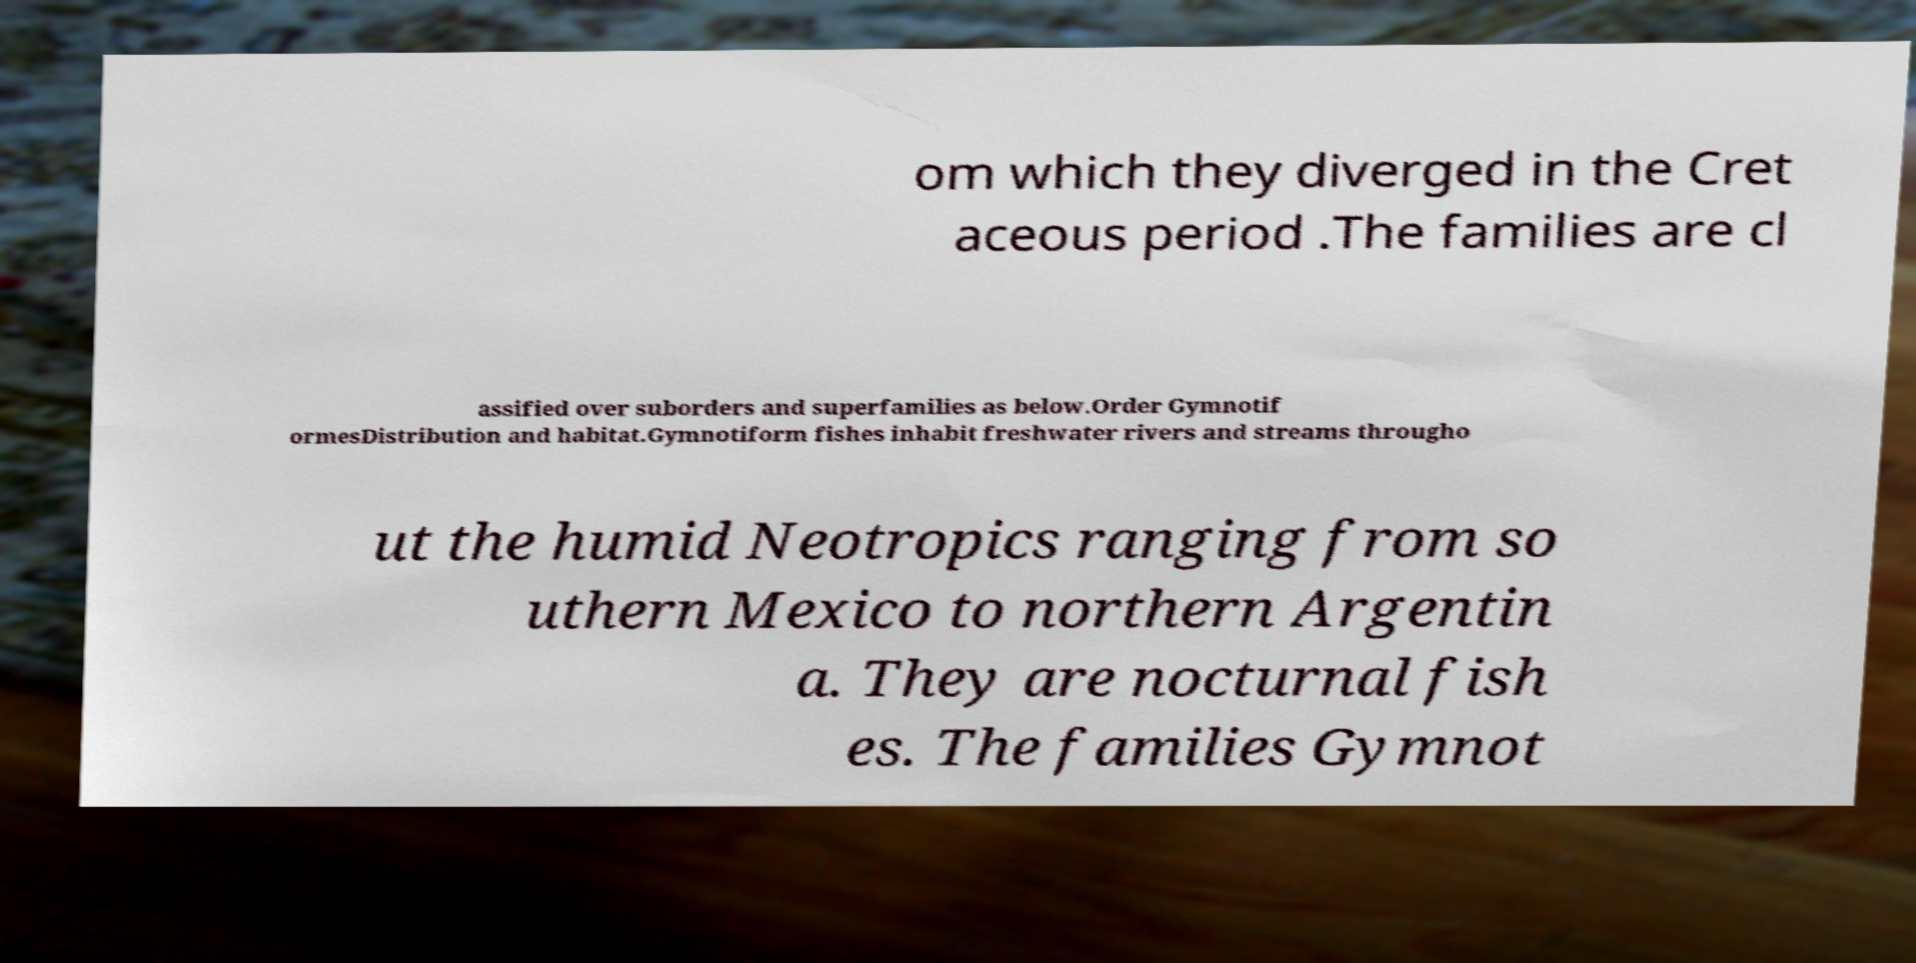Can you accurately transcribe the text from the provided image for me? om which they diverged in the Cret aceous period .The families are cl assified over suborders and superfamilies as below.Order Gymnotif ormesDistribution and habitat.Gymnotiform fishes inhabit freshwater rivers and streams througho ut the humid Neotropics ranging from so uthern Mexico to northern Argentin a. They are nocturnal fish es. The families Gymnot 